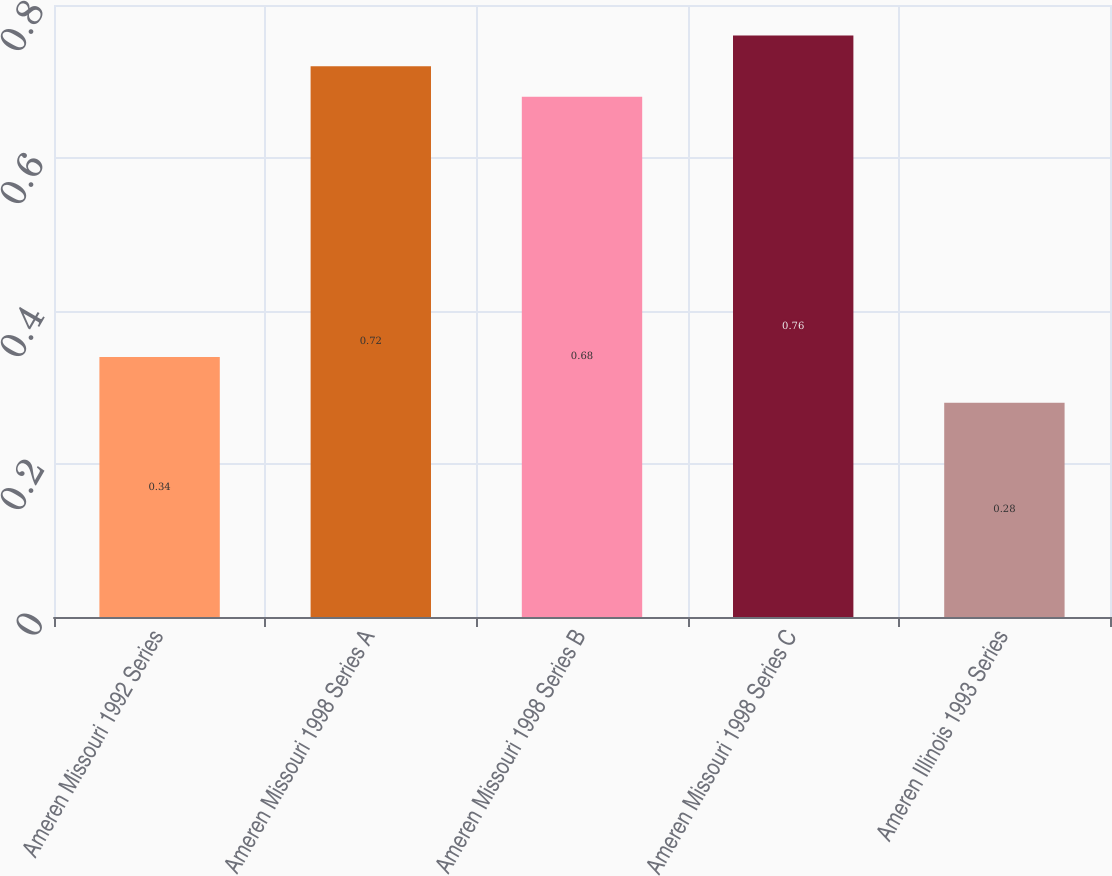<chart> <loc_0><loc_0><loc_500><loc_500><bar_chart><fcel>Ameren Missouri 1992 Series<fcel>Ameren Missouri 1998 Series A<fcel>Ameren Missouri 1998 Series B<fcel>Ameren Missouri 1998 Series C<fcel>Ameren Illinois 1993 Series<nl><fcel>0.34<fcel>0.72<fcel>0.68<fcel>0.76<fcel>0.28<nl></chart> 